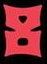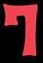What text appears in these images from left to right, separated by a semicolon? 8; 7 